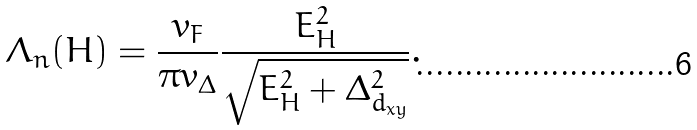Convert formula to latex. <formula><loc_0><loc_0><loc_500><loc_500>\Lambda _ { n } ( H ) = \frac { v _ { F } } { \pi v _ { \Delta } } \frac { E _ { H } ^ { 2 } } { \sqrt { E _ { H } ^ { 2 } + \Delta ^ { 2 } _ { d _ { x y } } } } .</formula> 